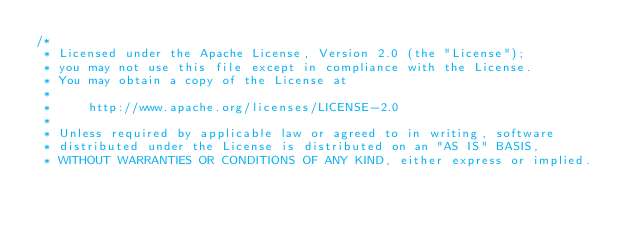Convert code to text. <code><loc_0><loc_0><loc_500><loc_500><_Java_>/*
 * Licensed under the Apache License, Version 2.0 (the "License");
 * you may not use this file except in compliance with the License.
 * You may obtain a copy of the License at
 *
 *     http://www.apache.org/licenses/LICENSE-2.0
 *
 * Unless required by applicable law or agreed to in writing, software
 * distributed under the License is distributed on an "AS IS" BASIS,
 * WITHOUT WARRANTIES OR CONDITIONS OF ANY KIND, either express or implied.</code> 